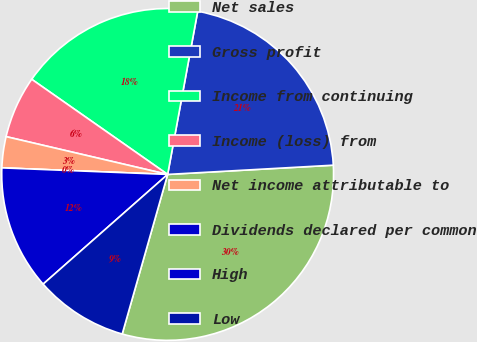Convert chart to OTSL. <chart><loc_0><loc_0><loc_500><loc_500><pie_chart><fcel>Net sales<fcel>Gross profit<fcel>Income from continuing<fcel>Income (loss) from<fcel>Net income attributable to<fcel>Dividends declared per common<fcel>High<fcel>Low<nl><fcel>30.3%<fcel>21.21%<fcel>18.18%<fcel>6.06%<fcel>3.03%<fcel>0.0%<fcel>12.12%<fcel>9.09%<nl></chart> 